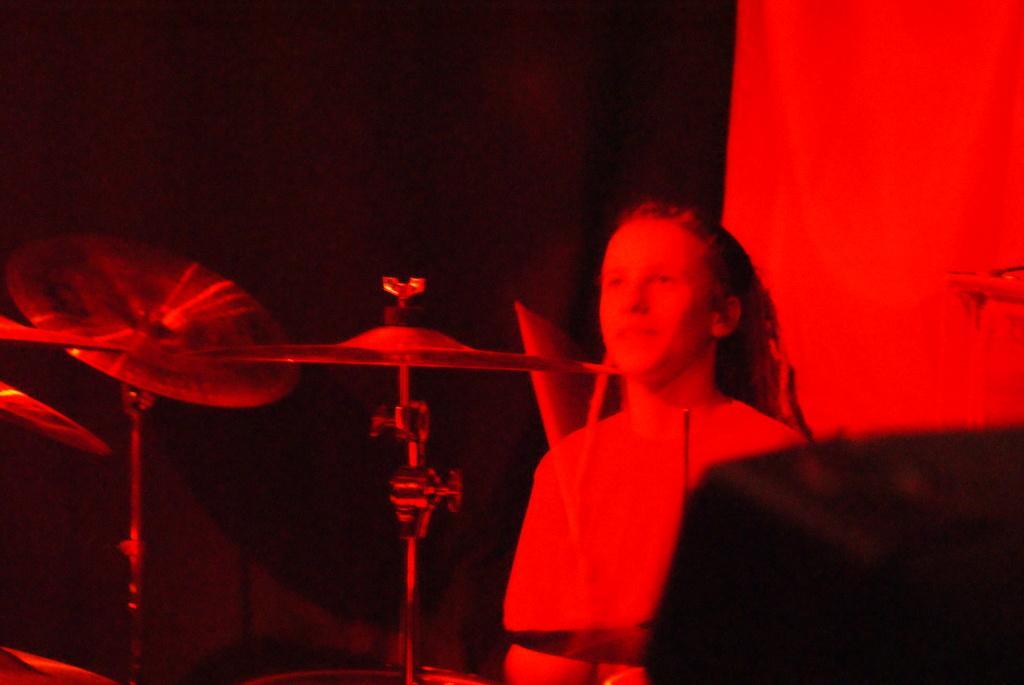Please provide a concise description of this image. In this image we can see a woman is standing, there are musical drums, the background is dark. 